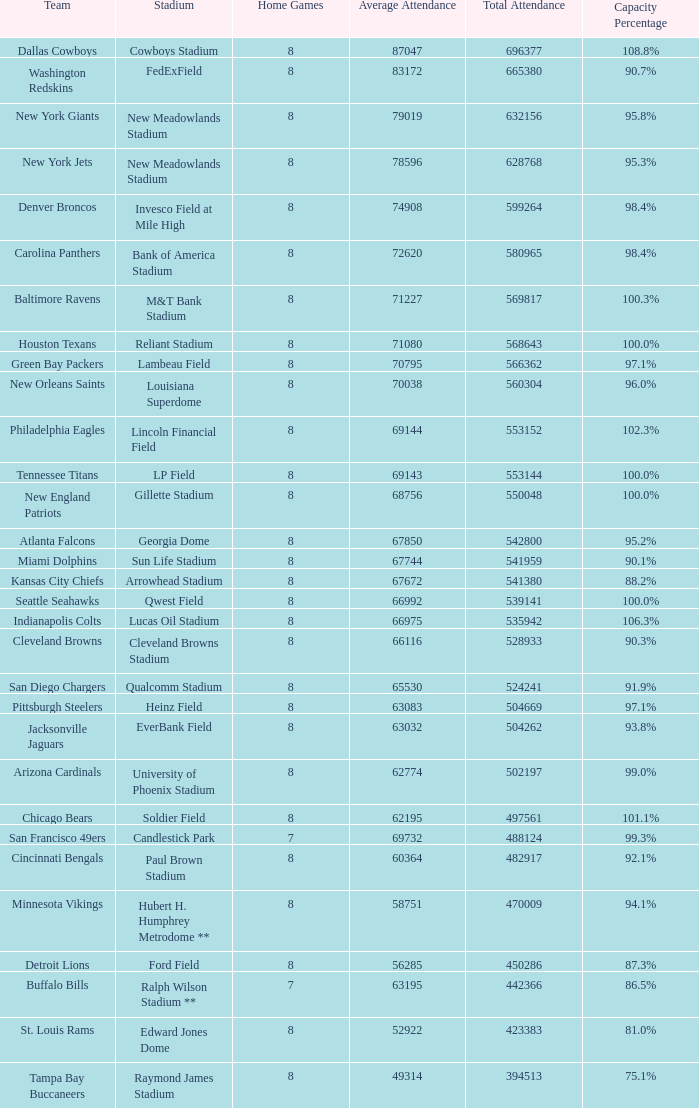What was average attendance when total attendance was 541380? 67672.0. 